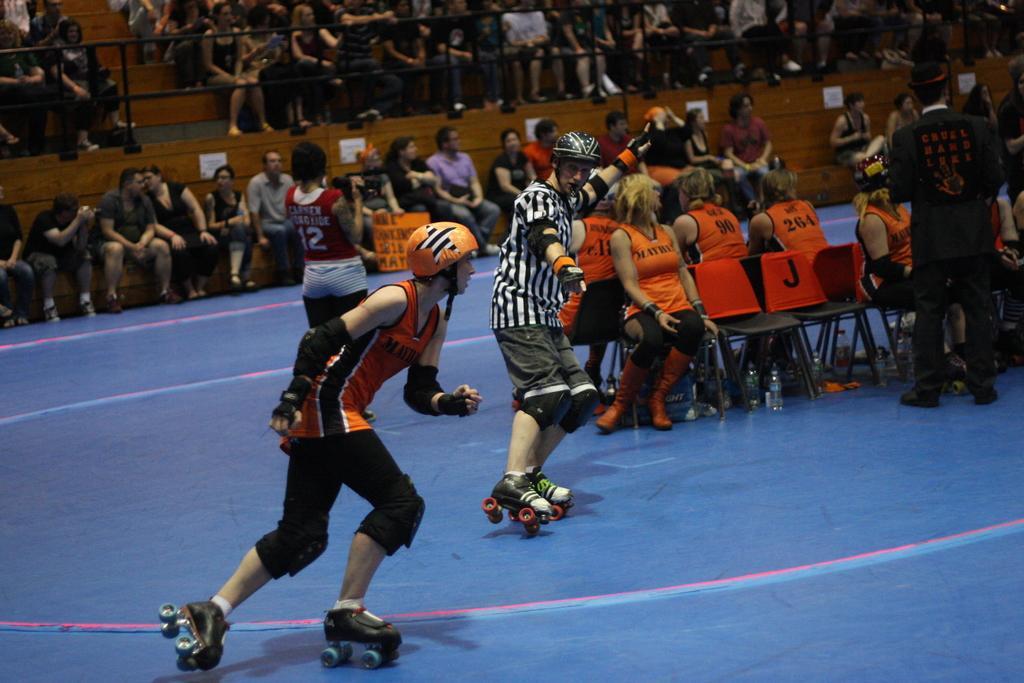How would you summarize this image in a sentence or two? In this image we can see two persons wearing helmets and skating on the floor. In the background we can see a few people sitting on the chairs. We can also see the persons standing in this image. Fence and stairs are visible. 